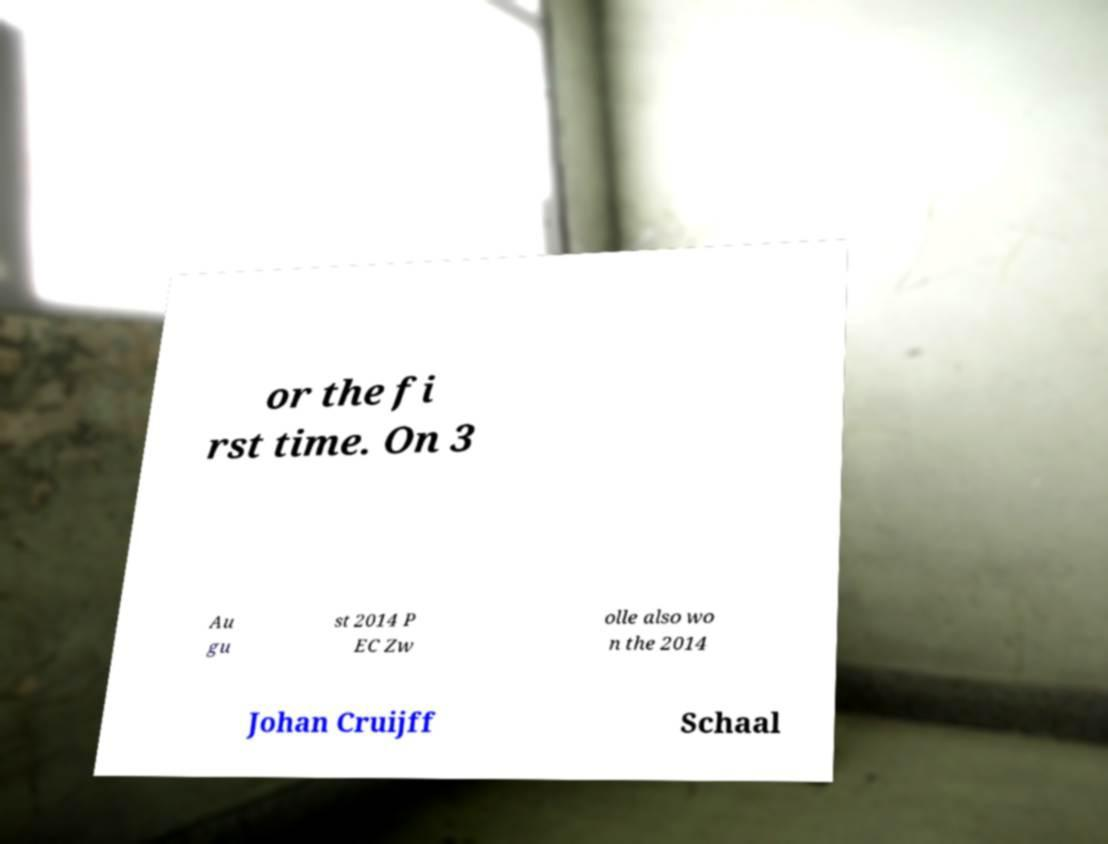Can you accurately transcribe the text from the provided image for me? or the fi rst time. On 3 Au gu st 2014 P EC Zw olle also wo n the 2014 Johan Cruijff Schaal 